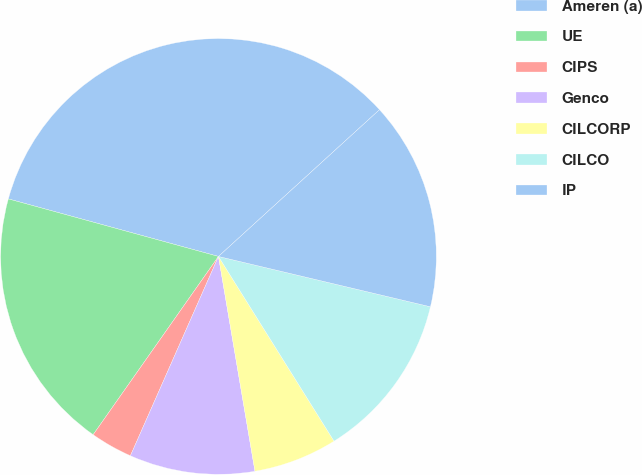Convert chart to OTSL. <chart><loc_0><loc_0><loc_500><loc_500><pie_chart><fcel>Ameren (a)<fcel>UE<fcel>CIPS<fcel>Genco<fcel>CILCORP<fcel>CILCO<fcel>IP<nl><fcel>33.98%<fcel>19.5%<fcel>3.13%<fcel>9.3%<fcel>6.22%<fcel>12.39%<fcel>15.47%<nl></chart> 